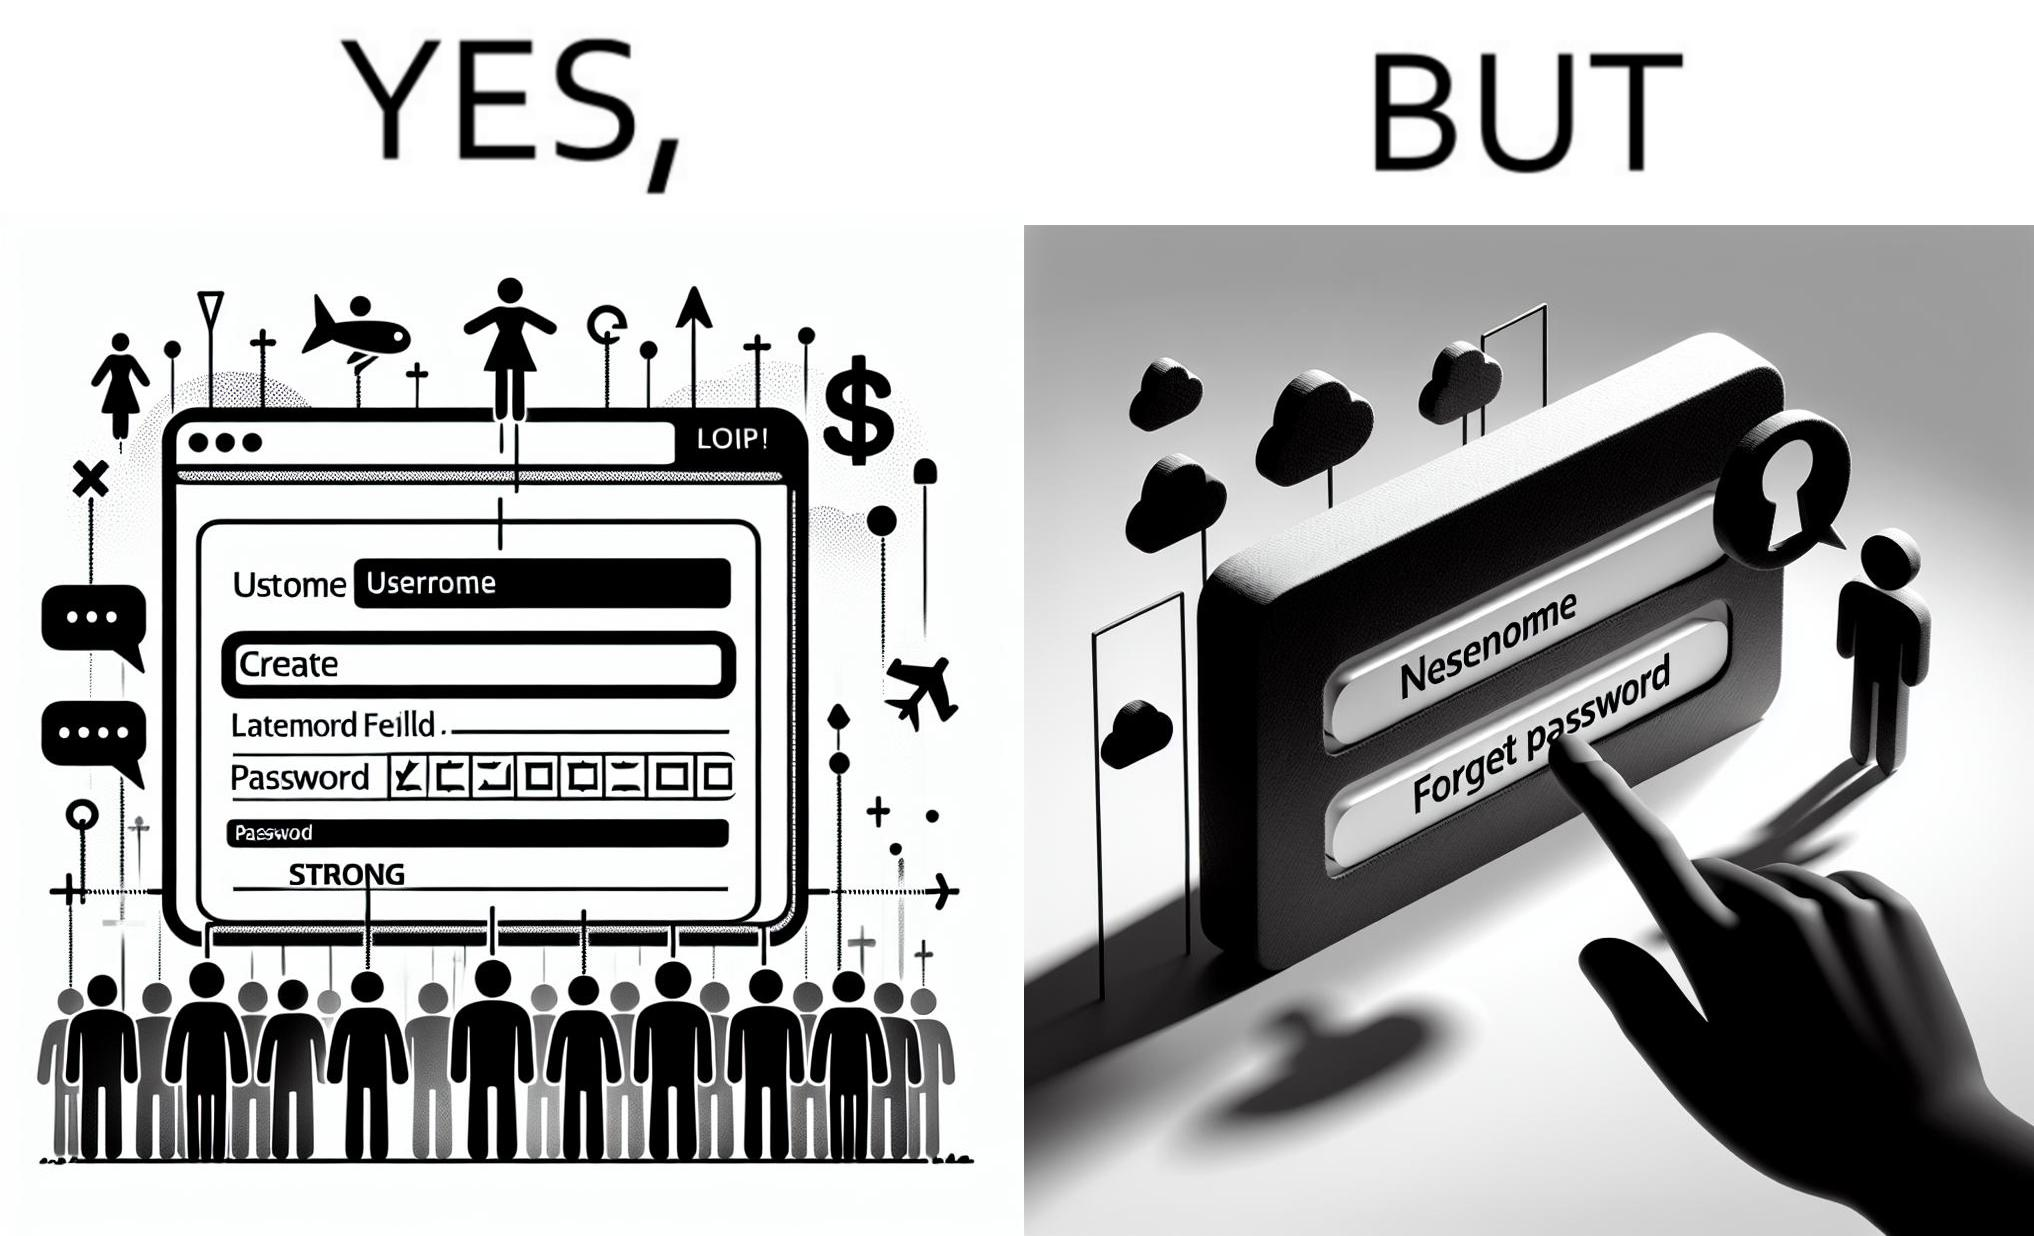Explain the humor or irony in this image. The image is ironic, because people set such a strong passwords for their accounts that they even forget the password and need to reset them 